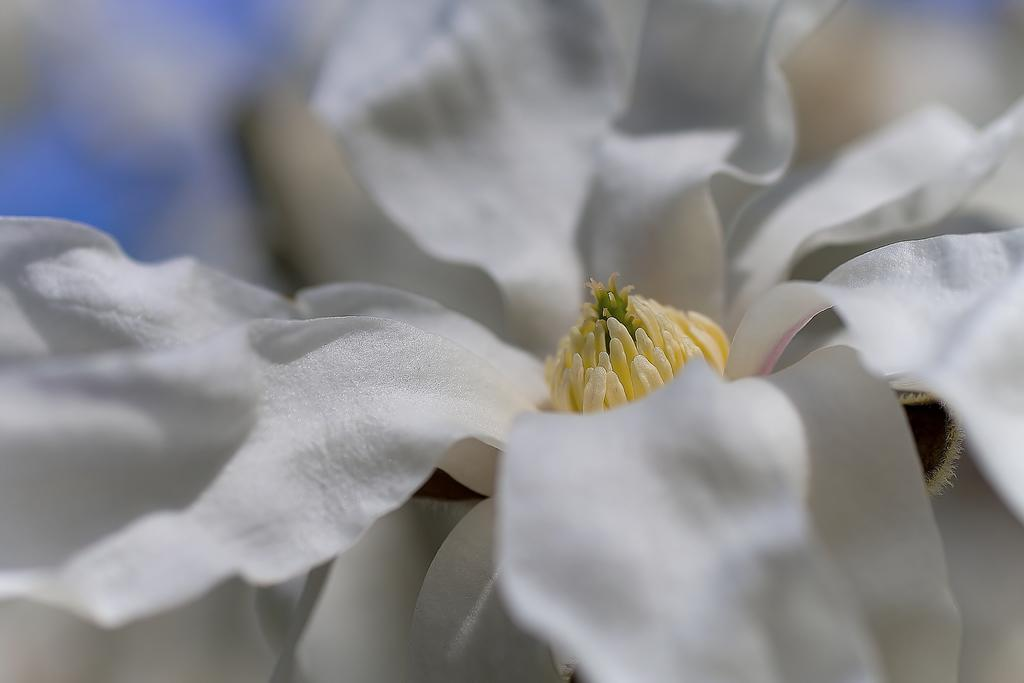What is the main subject of the image? There is a flower in the image. What color is the flower? The flower is white in color. Can you describe any other colors present in the image? There is a blue color in the left corner of the image. How many units of dust can be seen on the flower in the image? There is no dust present on the flower in the image. What type of room is the flower located in? The provided facts do not mention a room, so it cannot be determined from the image. 